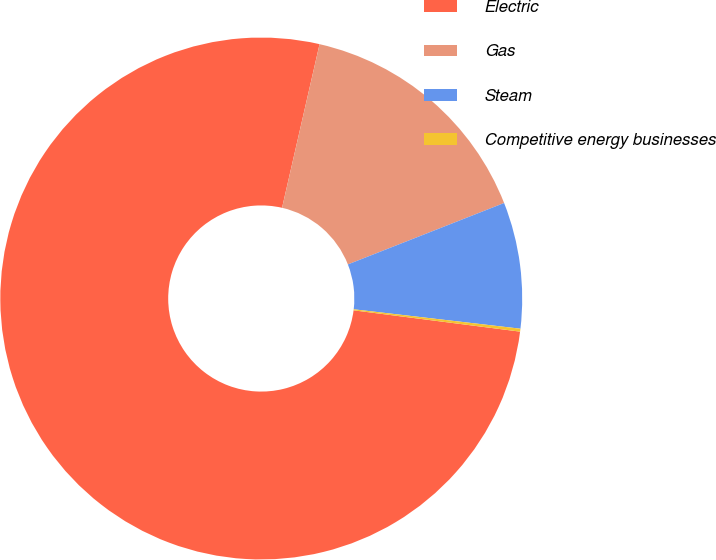Convert chart. <chart><loc_0><loc_0><loc_500><loc_500><pie_chart><fcel>Electric<fcel>Gas<fcel>Steam<fcel>Competitive energy businesses<nl><fcel>76.56%<fcel>15.45%<fcel>7.81%<fcel>0.18%<nl></chart> 